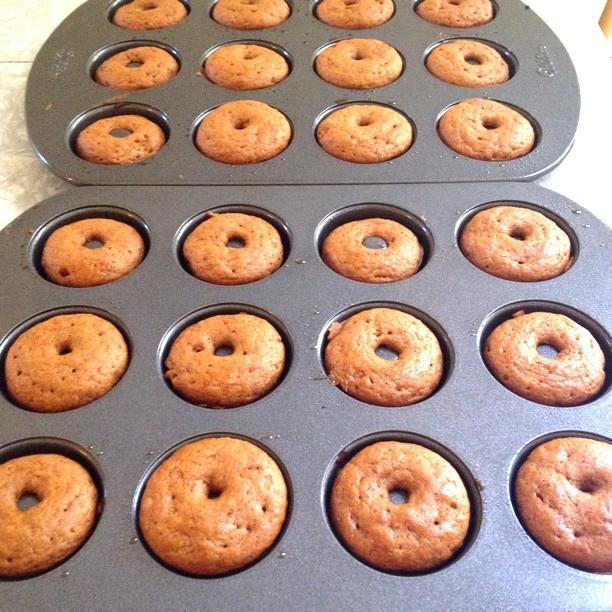What color are the donuts made from this strange pan?
Choose the correct response, then elucidate: 'Answer: answer
Rationale: rationale.'
Options: Brown, black, purple, white. Answer: brown.
Rationale: The pastries in this pan are a pale orangeish brown. 